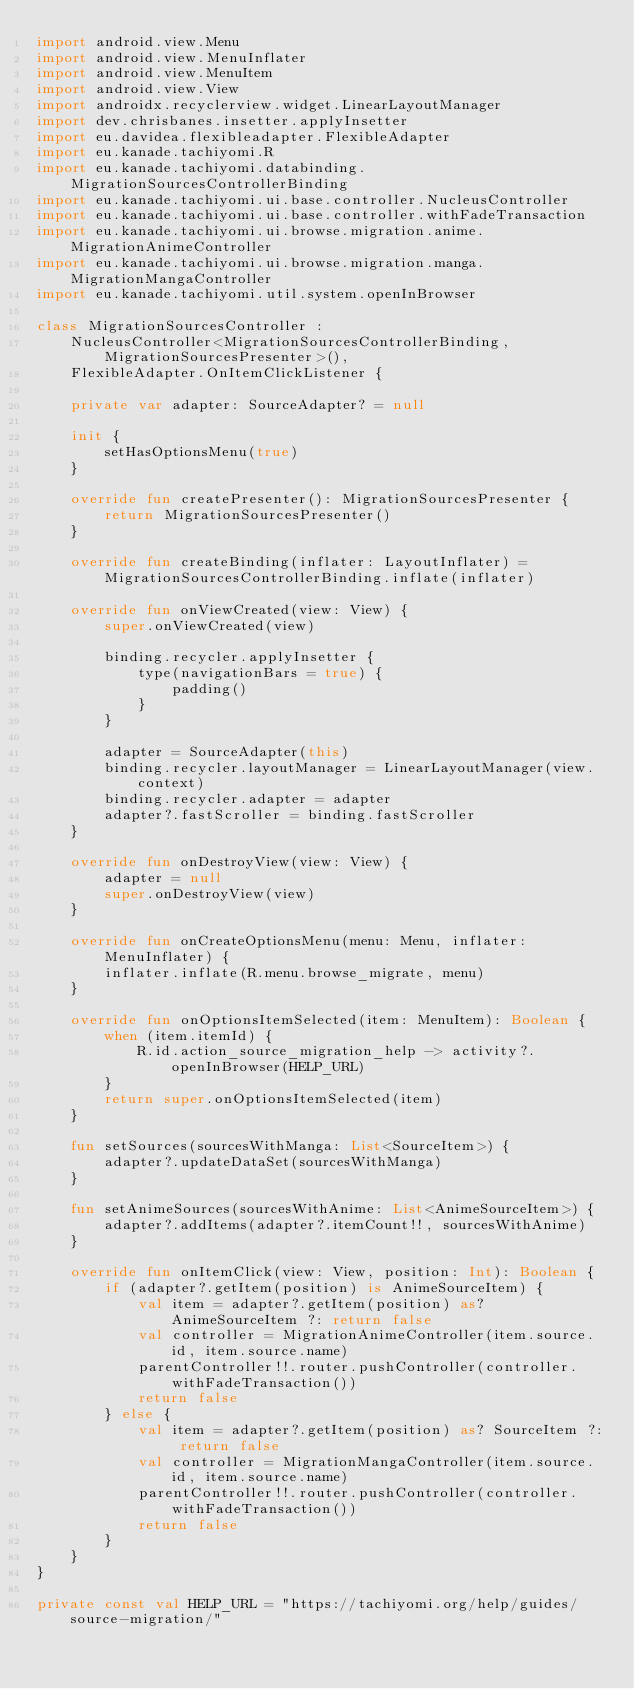Convert code to text. <code><loc_0><loc_0><loc_500><loc_500><_Kotlin_>import android.view.Menu
import android.view.MenuInflater
import android.view.MenuItem
import android.view.View
import androidx.recyclerview.widget.LinearLayoutManager
import dev.chrisbanes.insetter.applyInsetter
import eu.davidea.flexibleadapter.FlexibleAdapter
import eu.kanade.tachiyomi.R
import eu.kanade.tachiyomi.databinding.MigrationSourcesControllerBinding
import eu.kanade.tachiyomi.ui.base.controller.NucleusController
import eu.kanade.tachiyomi.ui.base.controller.withFadeTransaction
import eu.kanade.tachiyomi.ui.browse.migration.anime.MigrationAnimeController
import eu.kanade.tachiyomi.ui.browse.migration.manga.MigrationMangaController
import eu.kanade.tachiyomi.util.system.openInBrowser

class MigrationSourcesController :
    NucleusController<MigrationSourcesControllerBinding, MigrationSourcesPresenter>(),
    FlexibleAdapter.OnItemClickListener {

    private var adapter: SourceAdapter? = null

    init {
        setHasOptionsMenu(true)
    }

    override fun createPresenter(): MigrationSourcesPresenter {
        return MigrationSourcesPresenter()
    }

    override fun createBinding(inflater: LayoutInflater) = MigrationSourcesControllerBinding.inflate(inflater)

    override fun onViewCreated(view: View) {
        super.onViewCreated(view)

        binding.recycler.applyInsetter {
            type(navigationBars = true) {
                padding()
            }
        }

        adapter = SourceAdapter(this)
        binding.recycler.layoutManager = LinearLayoutManager(view.context)
        binding.recycler.adapter = adapter
        adapter?.fastScroller = binding.fastScroller
    }

    override fun onDestroyView(view: View) {
        adapter = null
        super.onDestroyView(view)
    }

    override fun onCreateOptionsMenu(menu: Menu, inflater: MenuInflater) {
        inflater.inflate(R.menu.browse_migrate, menu)
    }

    override fun onOptionsItemSelected(item: MenuItem): Boolean {
        when (item.itemId) {
            R.id.action_source_migration_help -> activity?.openInBrowser(HELP_URL)
        }
        return super.onOptionsItemSelected(item)
    }

    fun setSources(sourcesWithManga: List<SourceItem>) {
        adapter?.updateDataSet(sourcesWithManga)
    }

    fun setAnimeSources(sourcesWithAnime: List<AnimeSourceItem>) {
        adapter?.addItems(adapter?.itemCount!!, sourcesWithAnime)
    }

    override fun onItemClick(view: View, position: Int): Boolean {
        if (adapter?.getItem(position) is AnimeSourceItem) {
            val item = adapter?.getItem(position) as? AnimeSourceItem ?: return false
            val controller = MigrationAnimeController(item.source.id, item.source.name)
            parentController!!.router.pushController(controller.withFadeTransaction())
            return false
        } else {
            val item = adapter?.getItem(position) as? SourceItem ?: return false
            val controller = MigrationMangaController(item.source.id, item.source.name)
            parentController!!.router.pushController(controller.withFadeTransaction())
            return false
        }
    }
}

private const val HELP_URL = "https://tachiyomi.org/help/guides/source-migration/"
</code> 